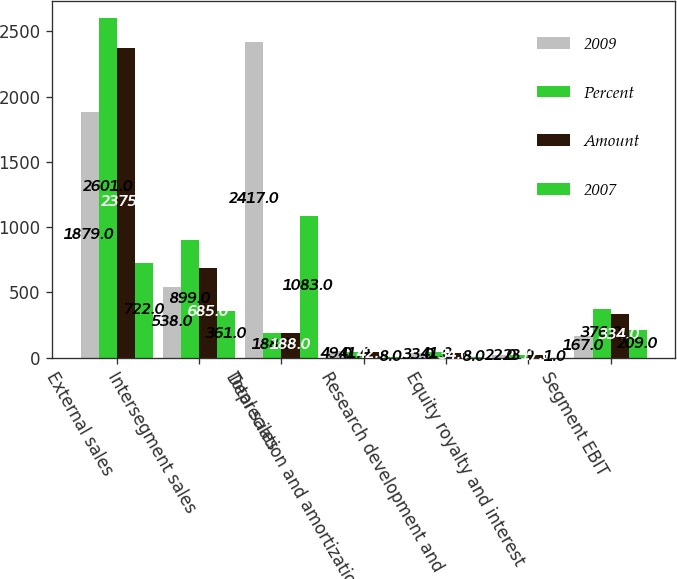Convert chart to OTSL. <chart><loc_0><loc_0><loc_500><loc_500><stacked_bar_chart><ecel><fcel>External sales<fcel>Intersegment sales<fcel>Total sales<fcel>Depreciation and amortization<fcel>Research development and<fcel>Equity royalty and interest<fcel>Segment EBIT<nl><fcel>2009<fcel>1879<fcel>538<fcel>2417<fcel>49<fcel>33<fcel>22<fcel>167<nl><fcel>Percent<fcel>2601<fcel>899<fcel>188<fcel>41<fcel>41<fcel>23<fcel>376<nl><fcel>Amount<fcel>2375<fcel>685<fcel>188<fcel>42<fcel>34<fcel>17<fcel>334<nl><fcel>2007<fcel>722<fcel>361<fcel>1083<fcel>8<fcel>8<fcel>1<fcel>209<nl></chart> 